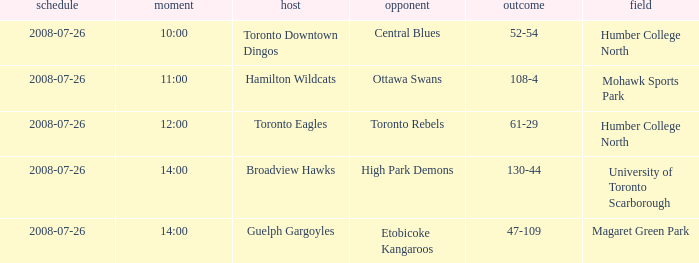Who has the Home Score of 52-54? Toronto Downtown Dingos. Could you help me parse every detail presented in this table? {'header': ['schedule', 'moment', 'host', 'opponent', 'outcome', 'field'], 'rows': [['2008-07-26', '10:00', 'Toronto Downtown Dingos', 'Central Blues', '52-54', 'Humber College North'], ['2008-07-26', '11:00', 'Hamilton Wildcats', 'Ottawa Swans', '108-4', 'Mohawk Sports Park'], ['2008-07-26', '12:00', 'Toronto Eagles', 'Toronto Rebels', '61-29', 'Humber College North'], ['2008-07-26', '14:00', 'Broadview Hawks', 'High Park Demons', '130-44', 'University of Toronto Scarborough'], ['2008-07-26', '14:00', 'Guelph Gargoyles', 'Etobicoke Kangaroos', '47-109', 'Magaret Green Park']]} 